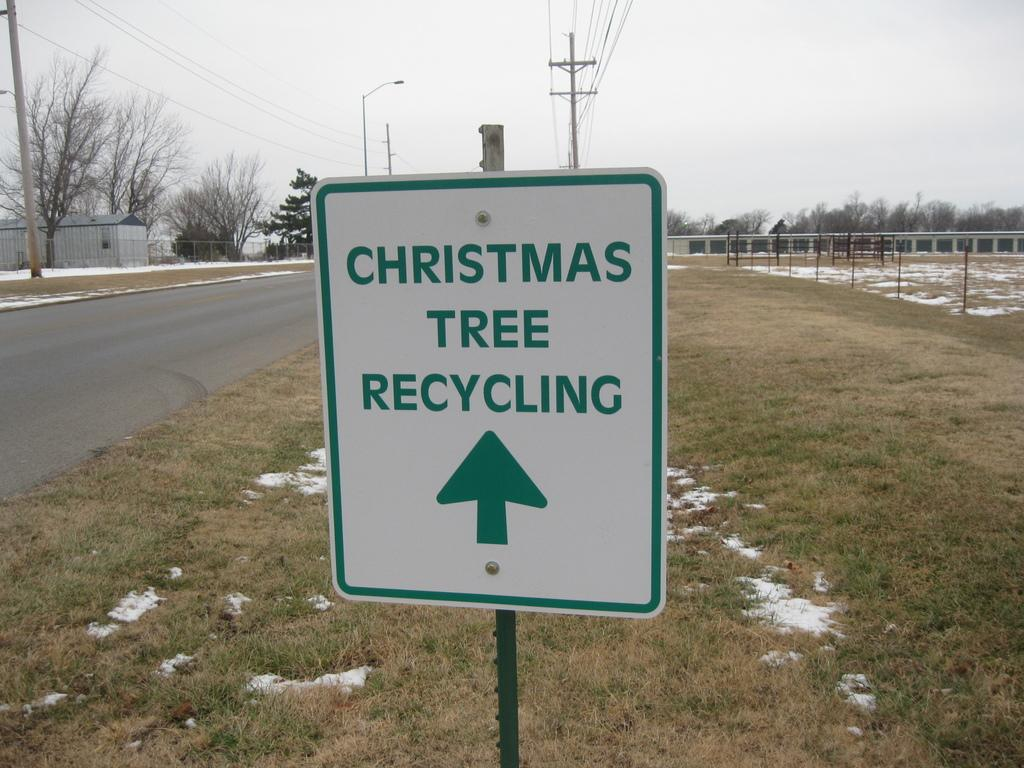<image>
Create a compact narrative representing the image presented. A sign on the side of the road that says, christmas tree recycling 